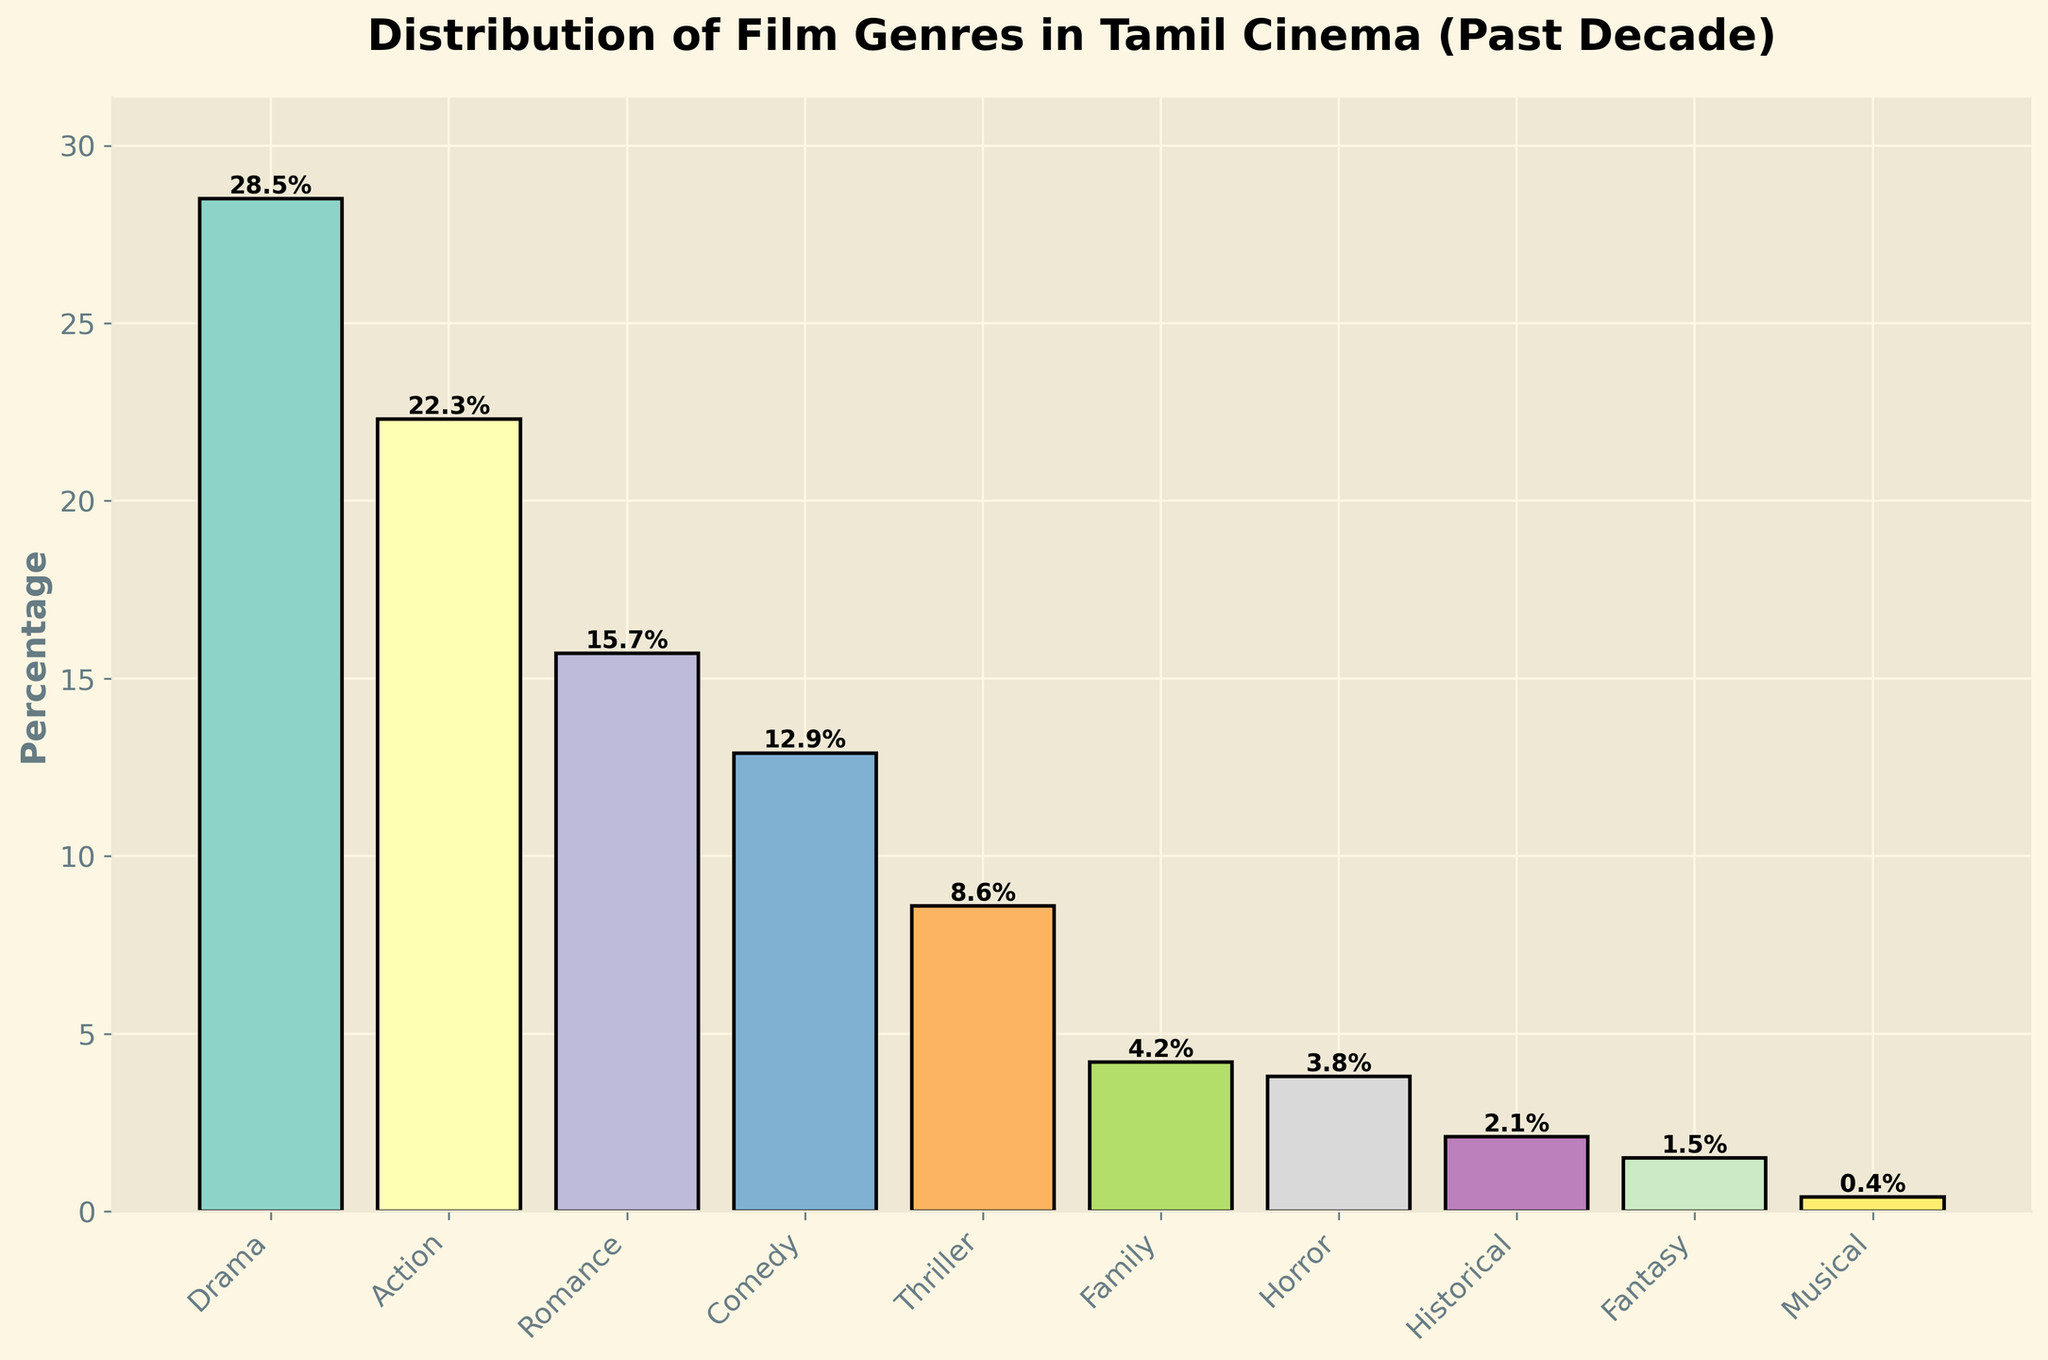What genre has the highest percentage in Tamil cinema over the past decade? The genre with the highest percentage is identified by looking at the tallest bar, which represents the largest percentage value. The tallest bar corresponds to Drama.
Answer: Drama What is the combined percentage of Action and Thriller genres? To find the combined percentage, add the individual percentages of the Action and Thriller genres. Action is 22.3% and Thriller is 8.6%, so the sum is 22.3% + 8.6%.
Answer: 30.9% Which genre has a lower percentage, Horror or Family? Compare the heights of the bars for the Horror and Family genres. Horror is 3.8% and Family is 4.2%, so Horror has the lower percentage.
Answer: Horror How much larger is the percentage of Comedy compared to Historical? Subtract the percentage of Historical from the percentage of Comedy to find the difference. Comedy is 12.9% and Historical is 2.1%, so the difference is 12.9% - 2.1%.
Answer: 10.8% What is the average percentage of the top three most prevalent genres? Identify the three genres with the highest percentages: Drama (28.5%), Action (22.3%), and Romance (15.7%). Calculate the average by summing these percentages and dividing by 3. The sum is 28.5% + 22.3% + 15.7% = 66.5%, and the average is 66.5% / 3.
Answer: 22.2% What percentage difference exists between the most and least popular genres? Identify the most popular genre (Drama at 28.5%) and the least popular genre (Musical at 0.4%). Subtract the least from the most to find the difference: 28.5% - 0.4%.
Answer: 28.1% How many genres have a percentage below 5%? Count the genres with bars representing less than 5%: Family (4.2%), Horror (3.8%), Historical (2.1%), Fantasy (1.5%), and Musical (0.4%). There are five genres meeting this criterion.
Answer: 5 What is the total percentage of genres classified as neither Drama, Action, nor Romance? Subtract the sum of Drama, Action, and Romance percentages from 100%. Drama (28.5%) + Action (22.3%) + Romance (15.7%) = 66.5%, so 100% - 66.5%.
Answer: 33.5% Is the percentage of Romance closer to the percentage of Comedy or Action? Calculate the differences between Romance and the other two genres. Romance (15.7%) - Comedy (12.9%) = 2.8% and Romance (15.7%) - Action (22.3%) = 6.6%. The smaller difference indicates that Romance is closer to Comedy.
Answer: Comedy 